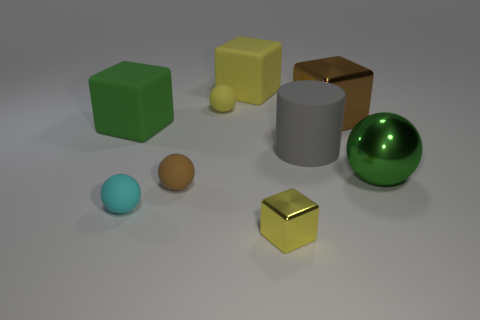Subtract all cyan cylinders. How many yellow cubes are left? 2 Add 1 large gray rubber cylinders. How many objects exist? 10 Subtract all big green balls. How many balls are left? 3 Subtract all green balls. How many balls are left? 3 Subtract all purple spheres. Subtract all purple cylinders. How many spheres are left? 4 Subtract all cylinders. How many objects are left? 8 Add 3 small brown balls. How many small brown balls are left? 4 Add 2 yellow cubes. How many yellow cubes exist? 4 Subtract 0 purple cubes. How many objects are left? 9 Subtract all big gray cylinders. Subtract all small cyan rubber things. How many objects are left? 7 